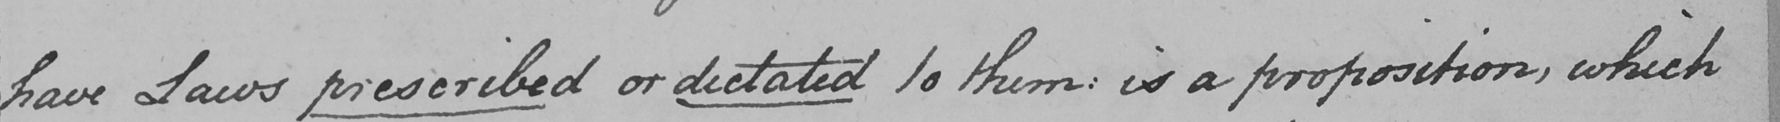Transcribe the text shown in this historical manuscript line. have Laws prescribed or dictated to them :  is a proposition , which 